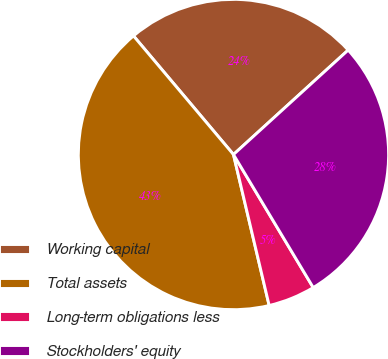Convert chart to OTSL. <chart><loc_0><loc_0><loc_500><loc_500><pie_chart><fcel>Working capital<fcel>Total assets<fcel>Long-term obligations less<fcel>Stockholders' equity<nl><fcel>24.39%<fcel>42.55%<fcel>4.9%<fcel>28.16%<nl></chart> 